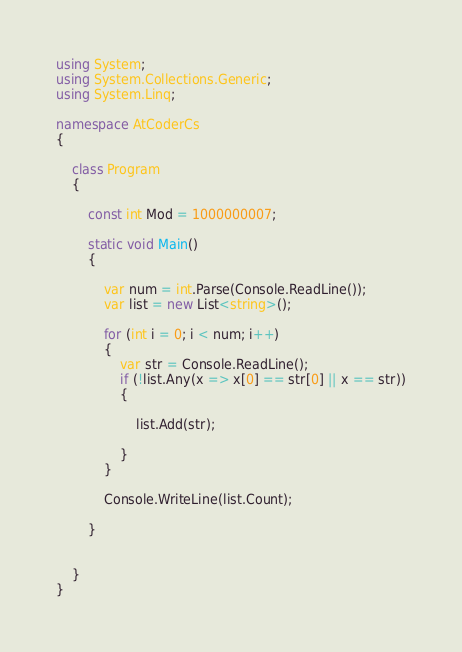<code> <loc_0><loc_0><loc_500><loc_500><_C#_>using System;
using System.Collections.Generic;
using System.Linq;

namespace AtCoderCs
{

    class Program
    {

        const int Mod = 1000000007;

        static void Main()
        {

            var num = int.Parse(Console.ReadLine());
            var list = new List<string>();

            for (int i = 0; i < num; i++)
            {
                var str = Console.ReadLine();
                if (!list.Any(x => x[0] == str[0] || x == str))
                {

                    list.Add(str);

                }
            }

            Console.WriteLine(list.Count);

        }


    }
}
</code> 